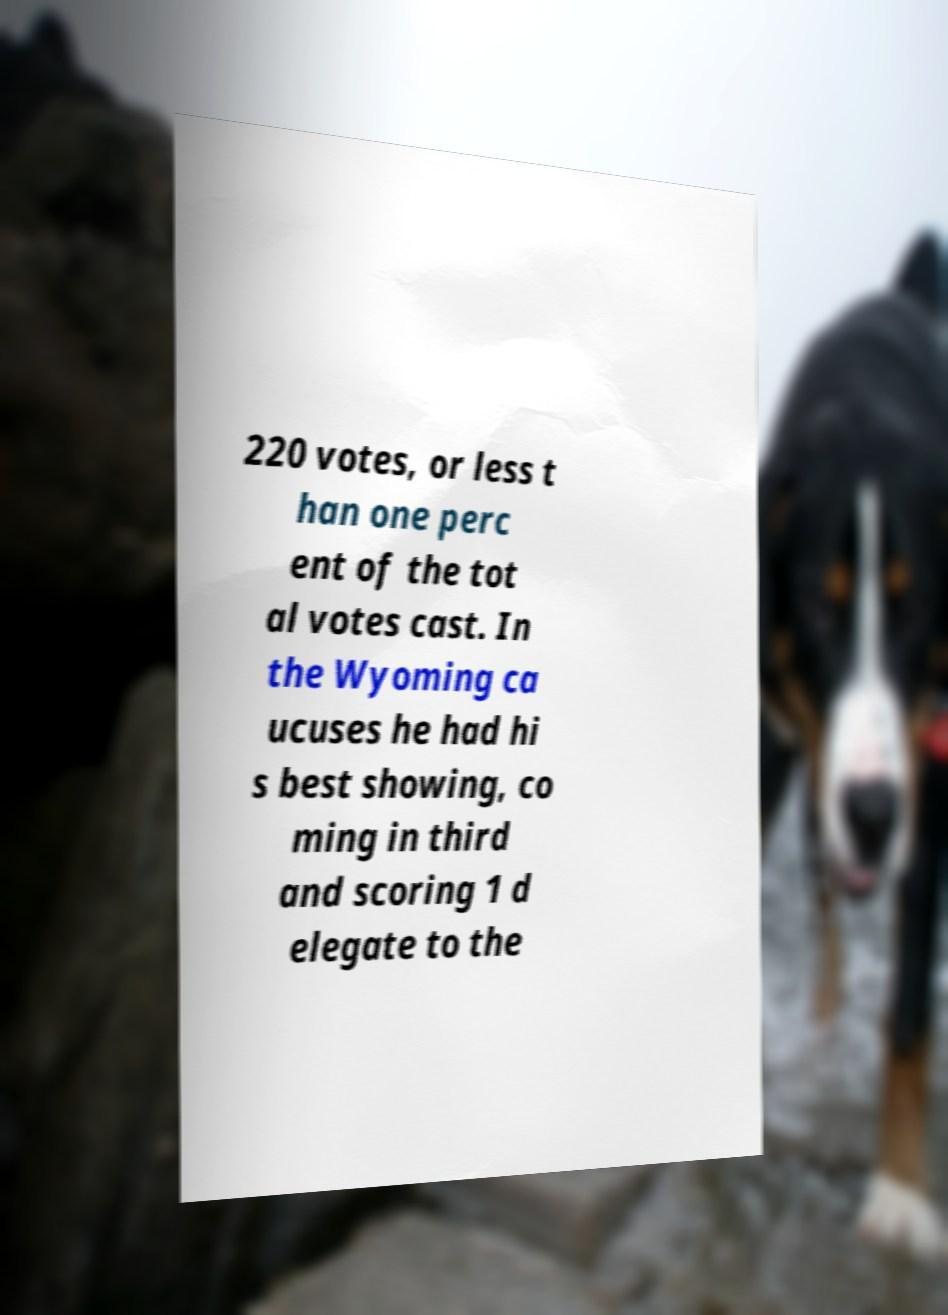Could you assist in decoding the text presented in this image and type it out clearly? 220 votes, or less t han one perc ent of the tot al votes cast. In the Wyoming ca ucuses he had hi s best showing, co ming in third and scoring 1 d elegate to the 